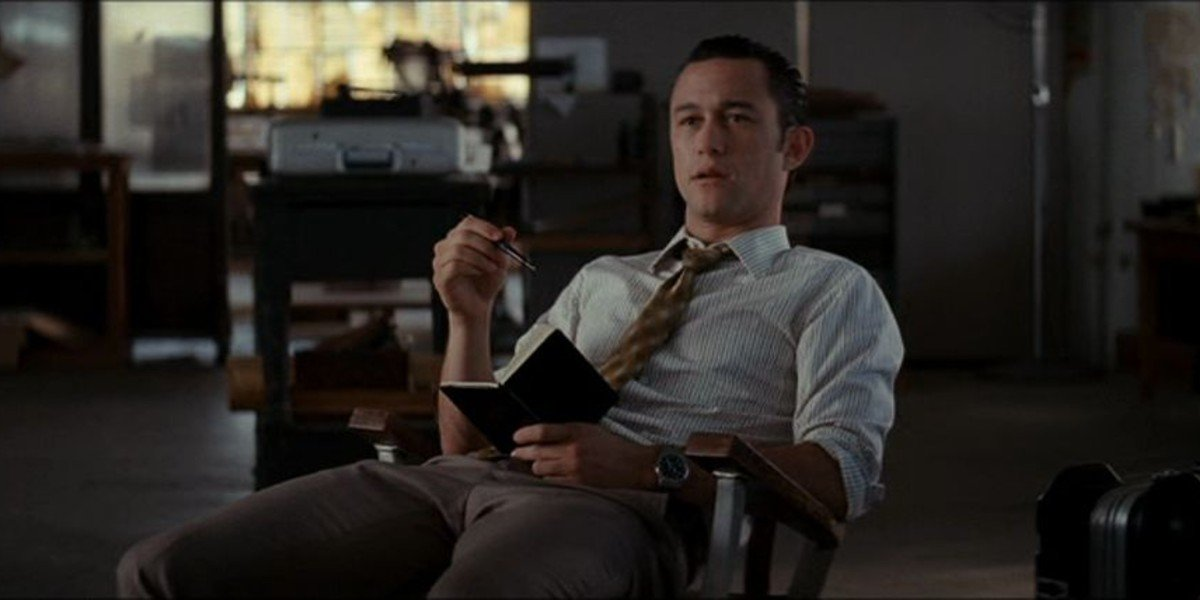What kind of note might he write next? Next, he might write a critical point or idea that just struck him, perhaps an innovative solution to a key issue he's been pondering. Alternatively, he might jot down an important observation he made during his recent meeting, or a brief outline for an upcoming project proposal. 